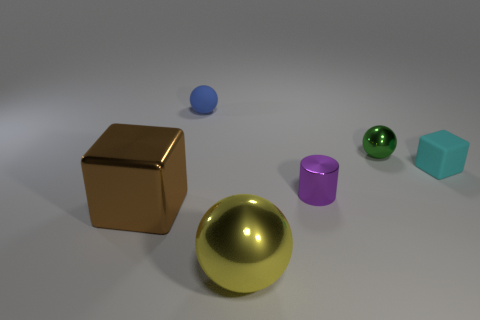What number of objects are large cyan shiny blocks or big metallic things left of the blue ball?
Provide a short and direct response. 1. The block that is left of the big shiny object to the right of the brown cube is what color?
Your response must be concise. Brown. How many other objects are there of the same material as the large yellow ball?
Offer a terse response. 3. How many shiny things are either brown cubes or large yellow things?
Offer a very short reply. 2. There is a tiny metal object that is the same shape as the tiny blue rubber object; what color is it?
Provide a succinct answer. Green. What number of things are red cylinders or small purple cylinders?
Provide a short and direct response. 1. The big yellow thing that is made of the same material as the large brown thing is what shape?
Ensure brevity in your answer.  Sphere. How many tiny objects are green things or brown cylinders?
Ensure brevity in your answer.  1. What number of tiny green balls are behind the small ball on the left side of the shiny ball that is on the left side of the small green shiny object?
Give a very brief answer. 0. Does the metallic sphere in front of the cyan matte cube have the same size as the big brown metal object?
Give a very brief answer. Yes. 